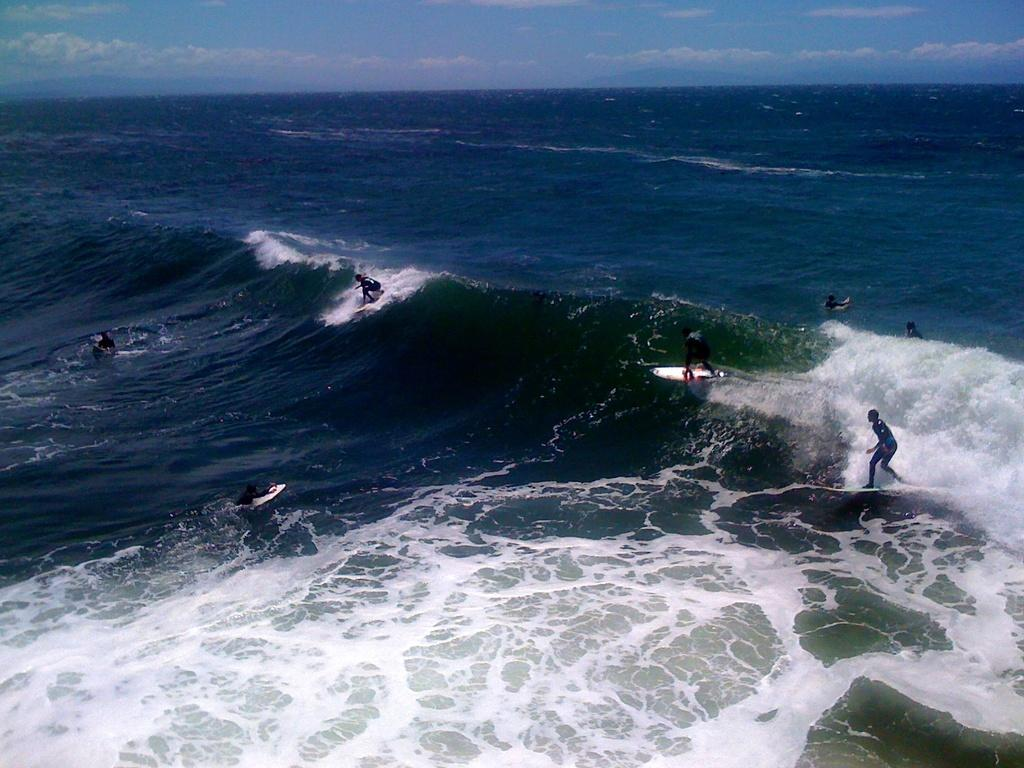What activity are the people in the image participating in? The people in the image are surfing. What equipment are the surfers using? The people are using surfboards. On what surface are the surfers riding? The surfing is taking place on water. What is visible at the top of the image? The sky is visible at the top of the image. Where is the mailbox located in the image? There is no mailbox present in the image; it features people surfing on water. What type of glue is being used by the surfers in the image? There is no glue present in the image; the surfers are using surfboards to ride the water. 